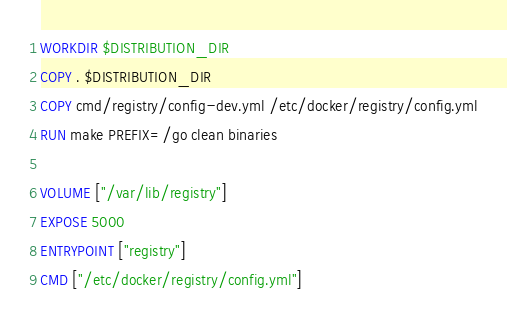<code> <loc_0><loc_0><loc_500><loc_500><_Dockerfile_>
WORKDIR $DISTRIBUTION_DIR
COPY . $DISTRIBUTION_DIR
COPY cmd/registry/config-dev.yml /etc/docker/registry/config.yml
RUN make PREFIX=/go clean binaries

VOLUME ["/var/lib/registry"]
EXPOSE 5000
ENTRYPOINT ["registry"]
CMD ["/etc/docker/registry/config.yml"]
</code> 